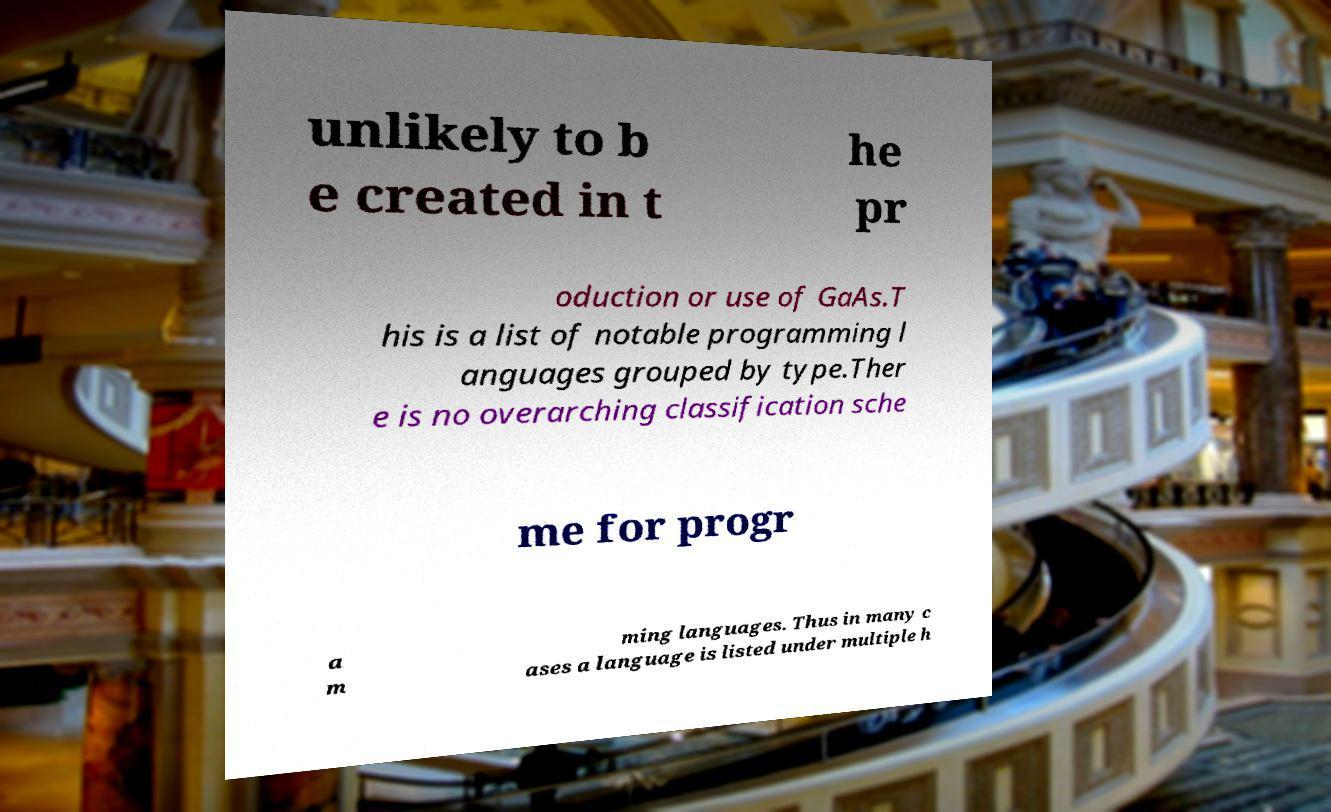Please identify and transcribe the text found in this image. unlikely to b e created in t he pr oduction or use of GaAs.T his is a list of notable programming l anguages grouped by type.Ther e is no overarching classification sche me for progr a m ming languages. Thus in many c ases a language is listed under multiple h 